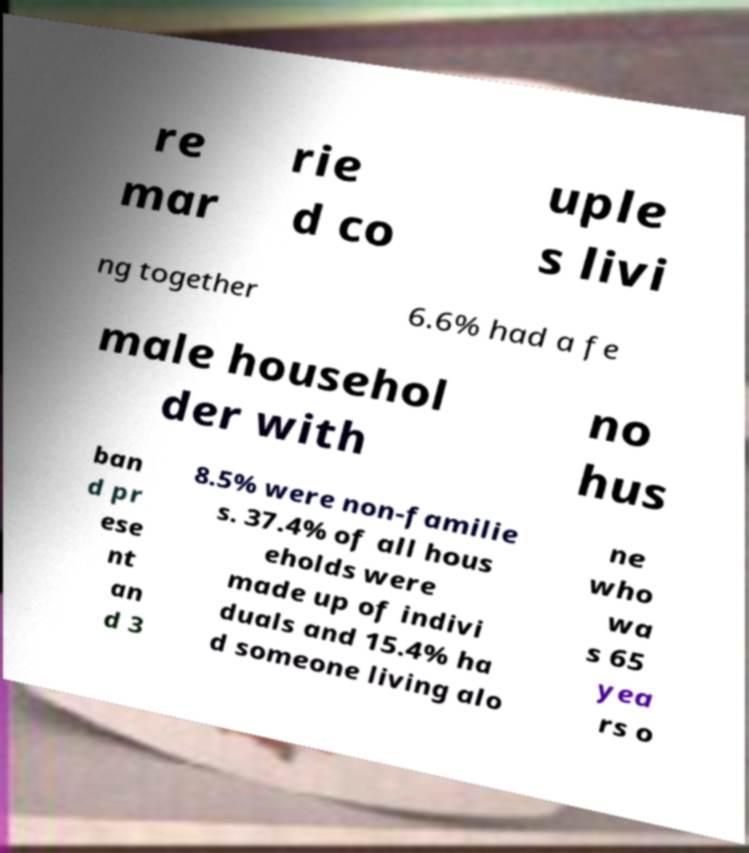Can you read and provide the text displayed in the image?This photo seems to have some interesting text. Can you extract and type it out for me? re mar rie d co uple s livi ng together 6.6% had a fe male househol der with no hus ban d pr ese nt an d 3 8.5% were non-familie s. 37.4% of all hous eholds were made up of indivi duals and 15.4% ha d someone living alo ne who wa s 65 yea rs o 